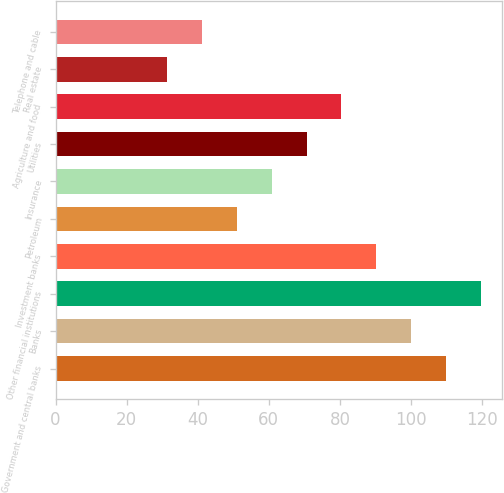Convert chart. <chart><loc_0><loc_0><loc_500><loc_500><bar_chart><fcel>Government and central banks<fcel>Banks<fcel>Other financial institutions<fcel>Investment banks<fcel>Petroleum<fcel>Insurance<fcel>Utilities<fcel>Agriculture and food<fcel>Real estate<fcel>Telephone and cable<nl><fcel>109.8<fcel>100<fcel>119.6<fcel>90.2<fcel>51<fcel>60.8<fcel>70.6<fcel>80.4<fcel>31.4<fcel>41.2<nl></chart> 